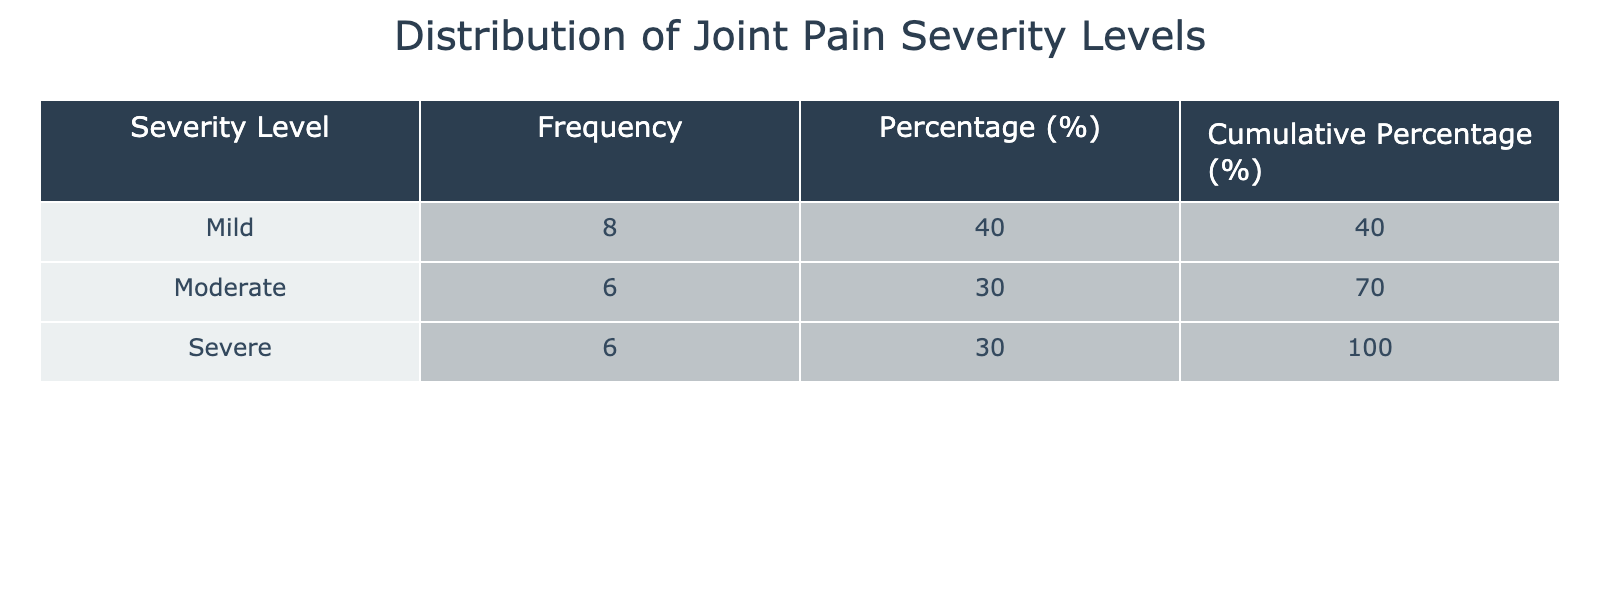What is the frequency of severe joint pain reported by patients? The frequency of severe joint pain is found in the frequency column corresponding to the "Severe" severity level. There are 5 patients who reported severe joint pain.
Answer: 5 What percentage of patients reported mild joint pain? To find the percentage of patients who reported mild joint pain, I look at the frequency for "Mild," which is 7. The total number of patients surveyed is 20, so the percentage is (7/20) * 100 = 35.0%.
Answer: 35.0% Is there any patient who reported moderate joint pain in the age group 20-29? I look through the table for the age group 20-29 under the "Moderate" severity level. There are no entries in this age group that report moderate joint pain.
Answer: No What is the cumulative percentage of patients who reported moderate joint pain or less? To find the cumulative percentage for moderate joint pain or less, I calculate the cumulative percentage for "Mild" (35.0%) and "Moderate" (25.0%). Summing these values gives 35.0 + 25.0 = 60.0%.
Answer: 60.0% How many patients reported severe joint pain over the age of 60? I need to identify severe joint pain cases and filter them based on age. From the table, the severities are in rows 10 (60-69) and 16 (70-79). Thus, 2 patients fit the criteria.
Answer: 2 What is the average age group of patients reporting mild joint pain? The age groups for "Mild" are 30-39 (2 patients), 60-69 (3 patients), 20-29 (2 patients), and 40-49 (1 patient). Representing these numerically as 35, 65, 25, and 45 and taking the average gives (2*35 + 3*65 + 2*25 + 1*45) / 8 = 48.75, which corresponds closest to the 40-49 age group overall.
Answer: 40-49 How many patients who reported severe joint pain are undergoing physical therapy? I look at the table for any entries that show "Severe" severity and then filter by "Physical Therapy." From the table, there are no patients with severe pain undergoing this treatment.
Answer: 0 Is the frequency of joint pain severity levels evenly distributed among the patients? To determine if the distribution is even, I analyze the frequency counts for all severity levels. The frequencies are not the same (e.g., 7 mild, 8 moderate, and 5 severe), indicating they are not evenly distributed.
Answer: No 